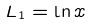<formula> <loc_0><loc_0><loc_500><loc_500>L _ { 1 } = \ln x</formula> 